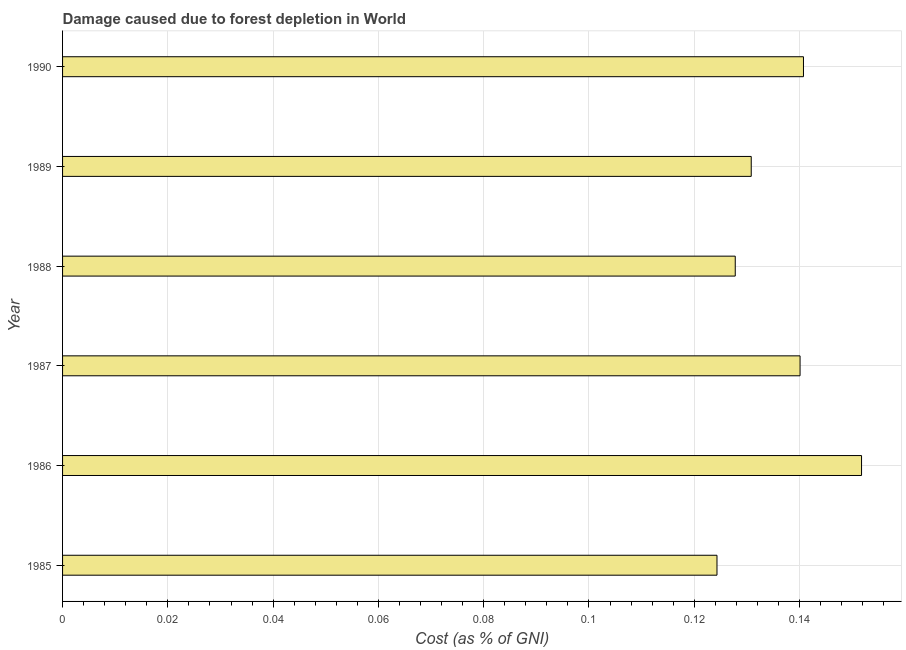Does the graph contain any zero values?
Your response must be concise. No. What is the title of the graph?
Offer a very short reply. Damage caused due to forest depletion in World. What is the label or title of the X-axis?
Offer a terse response. Cost (as % of GNI). What is the damage caused due to forest depletion in 1986?
Ensure brevity in your answer.  0.15. Across all years, what is the maximum damage caused due to forest depletion?
Your response must be concise. 0.15. Across all years, what is the minimum damage caused due to forest depletion?
Offer a terse response. 0.12. In which year was the damage caused due to forest depletion minimum?
Provide a short and direct response. 1985. What is the sum of the damage caused due to forest depletion?
Your answer should be compact. 0.82. What is the difference between the damage caused due to forest depletion in 1986 and 1988?
Offer a terse response. 0.02. What is the average damage caused due to forest depletion per year?
Provide a succinct answer. 0.14. What is the median damage caused due to forest depletion?
Keep it short and to the point. 0.14. In how many years, is the damage caused due to forest depletion greater than 0.128 %?
Your answer should be compact. 4. What is the ratio of the damage caused due to forest depletion in 1988 to that in 1989?
Provide a short and direct response. 0.98. Is the damage caused due to forest depletion in 1988 less than that in 1989?
Your response must be concise. Yes. Is the difference between the damage caused due to forest depletion in 1985 and 1988 greater than the difference between any two years?
Provide a succinct answer. No. What is the difference between the highest and the second highest damage caused due to forest depletion?
Keep it short and to the point. 0.01. In how many years, is the damage caused due to forest depletion greater than the average damage caused due to forest depletion taken over all years?
Offer a very short reply. 3. Are the values on the major ticks of X-axis written in scientific E-notation?
Offer a terse response. No. What is the Cost (as % of GNI) in 1985?
Provide a succinct answer. 0.12. What is the Cost (as % of GNI) in 1986?
Your answer should be compact. 0.15. What is the Cost (as % of GNI) in 1987?
Keep it short and to the point. 0.14. What is the Cost (as % of GNI) in 1988?
Your answer should be compact. 0.13. What is the Cost (as % of GNI) in 1989?
Offer a very short reply. 0.13. What is the Cost (as % of GNI) in 1990?
Your response must be concise. 0.14. What is the difference between the Cost (as % of GNI) in 1985 and 1986?
Your response must be concise. -0.03. What is the difference between the Cost (as % of GNI) in 1985 and 1987?
Your answer should be compact. -0.02. What is the difference between the Cost (as % of GNI) in 1985 and 1988?
Ensure brevity in your answer.  -0. What is the difference between the Cost (as % of GNI) in 1985 and 1989?
Your answer should be very brief. -0.01. What is the difference between the Cost (as % of GNI) in 1985 and 1990?
Your response must be concise. -0.02. What is the difference between the Cost (as % of GNI) in 1986 and 1987?
Ensure brevity in your answer.  0.01. What is the difference between the Cost (as % of GNI) in 1986 and 1988?
Your response must be concise. 0.02. What is the difference between the Cost (as % of GNI) in 1986 and 1989?
Make the answer very short. 0.02. What is the difference between the Cost (as % of GNI) in 1986 and 1990?
Keep it short and to the point. 0.01. What is the difference between the Cost (as % of GNI) in 1987 and 1988?
Your response must be concise. 0.01. What is the difference between the Cost (as % of GNI) in 1987 and 1989?
Ensure brevity in your answer.  0.01. What is the difference between the Cost (as % of GNI) in 1987 and 1990?
Offer a terse response. -0. What is the difference between the Cost (as % of GNI) in 1988 and 1989?
Offer a very short reply. -0. What is the difference between the Cost (as % of GNI) in 1988 and 1990?
Your answer should be compact. -0.01. What is the difference between the Cost (as % of GNI) in 1989 and 1990?
Make the answer very short. -0.01. What is the ratio of the Cost (as % of GNI) in 1985 to that in 1986?
Your answer should be compact. 0.82. What is the ratio of the Cost (as % of GNI) in 1985 to that in 1987?
Give a very brief answer. 0.89. What is the ratio of the Cost (as % of GNI) in 1985 to that in 1989?
Offer a very short reply. 0.95. What is the ratio of the Cost (as % of GNI) in 1985 to that in 1990?
Ensure brevity in your answer.  0.88. What is the ratio of the Cost (as % of GNI) in 1986 to that in 1987?
Offer a very short reply. 1.08. What is the ratio of the Cost (as % of GNI) in 1986 to that in 1988?
Keep it short and to the point. 1.19. What is the ratio of the Cost (as % of GNI) in 1986 to that in 1989?
Your answer should be compact. 1.16. What is the ratio of the Cost (as % of GNI) in 1986 to that in 1990?
Your answer should be very brief. 1.08. What is the ratio of the Cost (as % of GNI) in 1987 to that in 1988?
Make the answer very short. 1.1. What is the ratio of the Cost (as % of GNI) in 1987 to that in 1989?
Offer a very short reply. 1.07. What is the ratio of the Cost (as % of GNI) in 1987 to that in 1990?
Offer a terse response. 0.99. What is the ratio of the Cost (as % of GNI) in 1988 to that in 1990?
Your response must be concise. 0.91. 